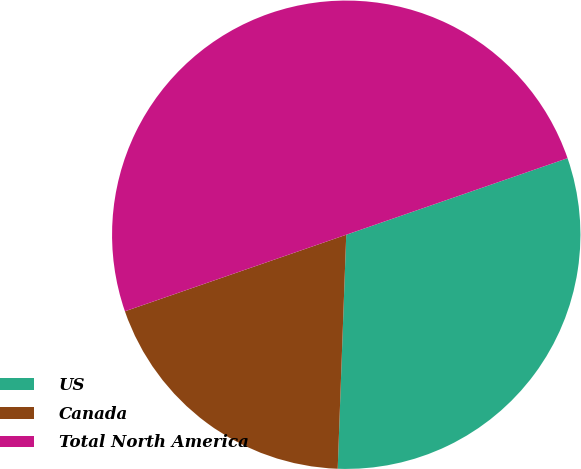Convert chart. <chart><loc_0><loc_0><loc_500><loc_500><pie_chart><fcel>US<fcel>Canada<fcel>Total North America<nl><fcel>30.88%<fcel>19.12%<fcel>50.0%<nl></chart> 